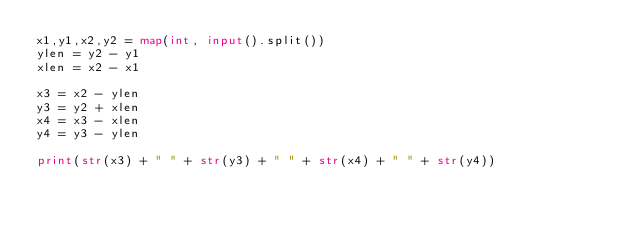<code> <loc_0><loc_0><loc_500><loc_500><_Python_>x1,y1,x2,y2 = map(int, input().split())
ylen = y2 - y1
xlen = x2 - x1

x3 = x2 - ylen
y3 = y2 + xlen
x4 = x3 - xlen
y4 = y3 - ylen

print(str(x3) + " " + str(y3) + " " + str(x4) + " " + str(y4)) </code> 